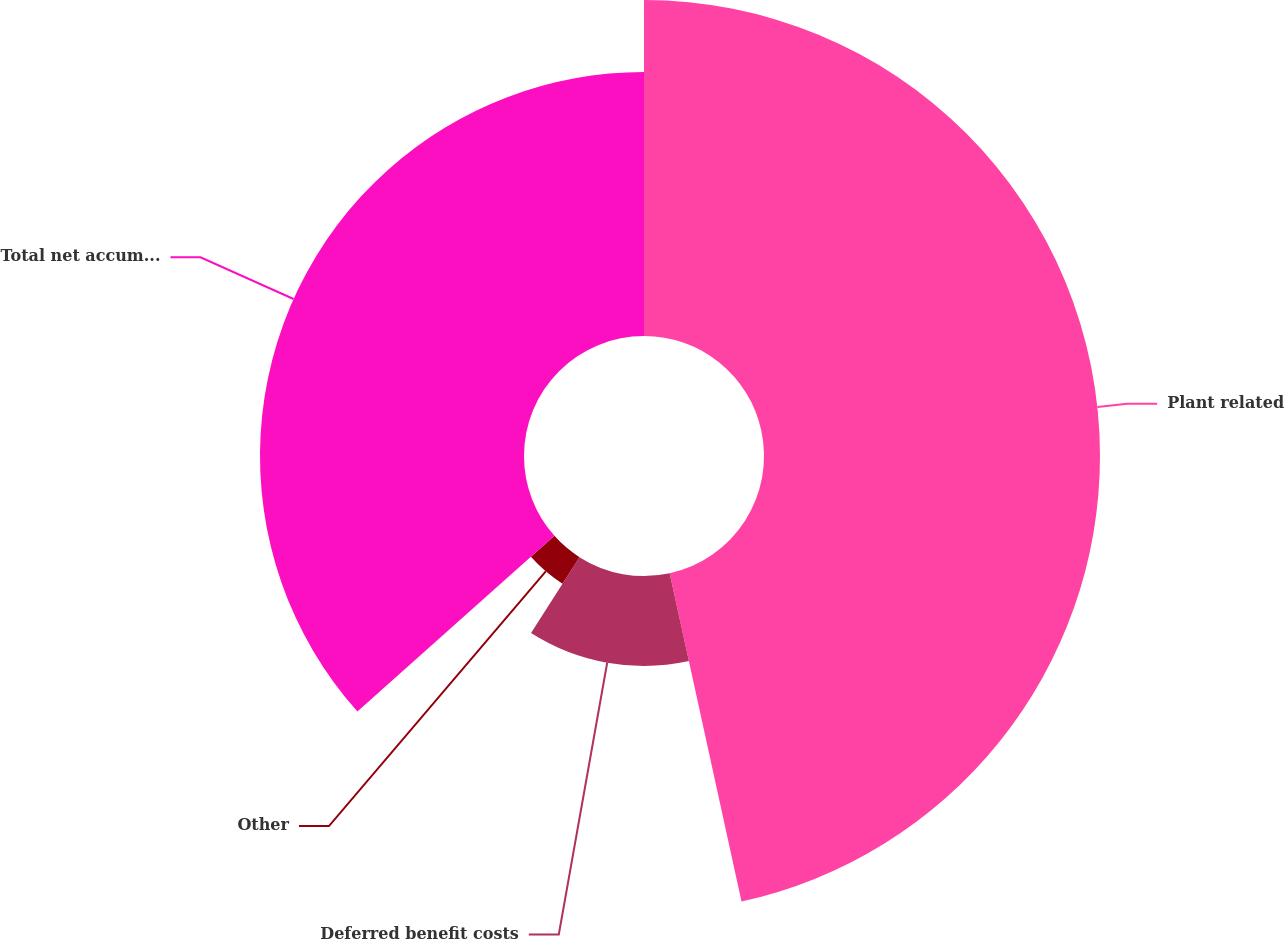Convert chart to OTSL. <chart><loc_0><loc_0><loc_500><loc_500><pie_chart><fcel>Plant related<fcel>Deferred benefit costs<fcel>Other<fcel>Total net accumulated deferred<nl><fcel>46.57%<fcel>12.47%<fcel>4.37%<fcel>36.59%<nl></chart> 